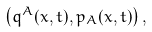Convert formula to latex. <formula><loc_0><loc_0><loc_500><loc_500>\left ( q ^ { A } ( x , t ) , p _ { A } ( x , t ) \right ) ,</formula> 